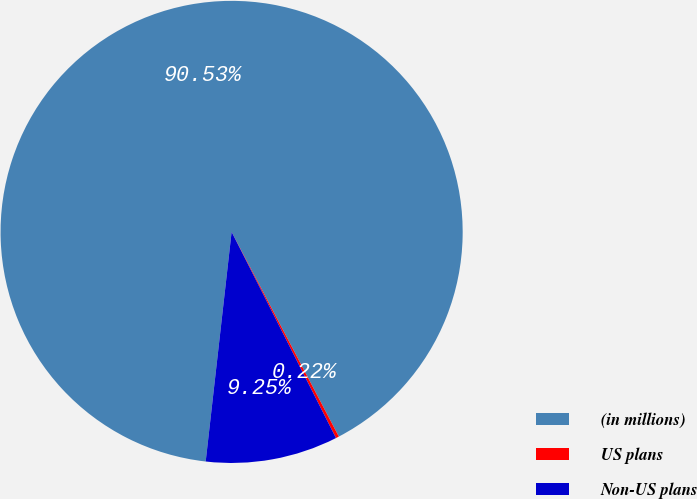Convert chart. <chart><loc_0><loc_0><loc_500><loc_500><pie_chart><fcel>(in millions)<fcel>US plans<fcel>Non-US plans<nl><fcel>90.52%<fcel>0.22%<fcel>9.25%<nl></chart> 